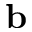Convert formula to latex. <formula><loc_0><loc_0><loc_500><loc_500>b</formula> 